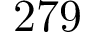<formula> <loc_0><loc_0><loc_500><loc_500>2 7 9</formula> 